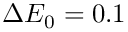<formula> <loc_0><loc_0><loc_500><loc_500>\Delta E _ { 0 } = 0 . 1</formula> 